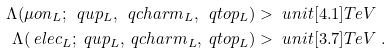Convert formula to latex. <formula><loc_0><loc_0><loc_500><loc_500>\Lambda ( \mu o n _ { L } ; \ q u p _ { L } , \ q c h a r m _ { L } , \ q t o p _ { L } ) & > \ u n i t [ 4 . 1 ] { T e V } \\ \Lambda ( \ e l e c _ { L } ; \ q u p _ { L } , \ q c h a r m _ { L } , \ q t o p _ { L } ) & > \ u n i t [ 3 . 7 ] { T e V } \ .</formula> 